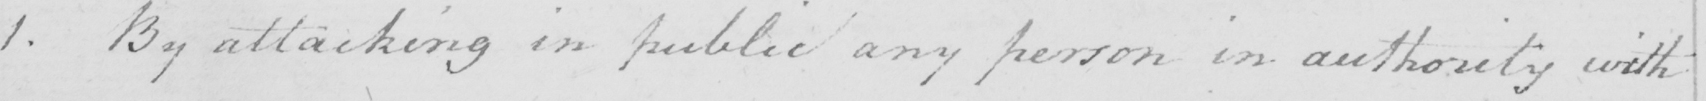Please transcribe the handwritten text in this image. 1 . By attacking in public any person in authority with 